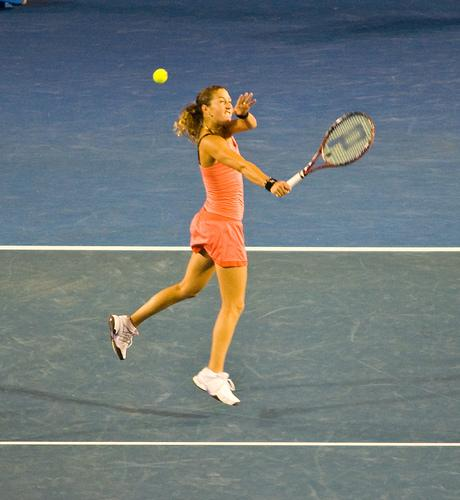Who supplied her tennis racket? Please explain your reasoning. prince. The woman is hitting a ball with her racket. 